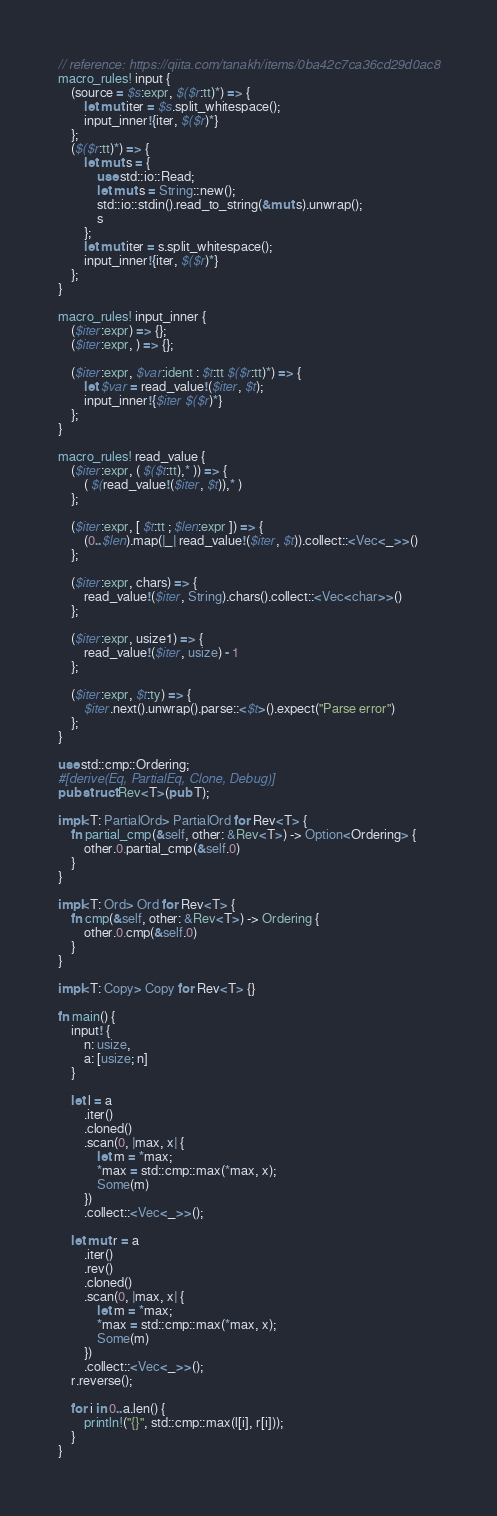<code> <loc_0><loc_0><loc_500><loc_500><_Rust_>// reference: https://qiita.com/tanakh/items/0ba42c7ca36cd29d0ac8
macro_rules! input {
    (source = $s:expr, $($r:tt)*) => {
        let mut iter = $s.split_whitespace();
        input_inner!{iter, $($r)*}
    };
    ($($r:tt)*) => {
        let mut s = {
            use std::io::Read;
            let mut s = String::new();
            std::io::stdin().read_to_string(&mut s).unwrap();
            s
        };
        let mut iter = s.split_whitespace();
        input_inner!{iter, $($r)*}
    };
}

macro_rules! input_inner {
    ($iter:expr) => {};
    ($iter:expr, ) => {};

    ($iter:expr, $var:ident : $t:tt $($r:tt)*) => {
        let $var = read_value!($iter, $t);
        input_inner!{$iter $($r)*}
    };
}

macro_rules! read_value {
    ($iter:expr, ( $($t:tt),* )) => {
        ( $(read_value!($iter, $t)),* )
    };

    ($iter:expr, [ $t:tt ; $len:expr ]) => {
        (0..$len).map(|_| read_value!($iter, $t)).collect::<Vec<_>>()
    };

    ($iter:expr, chars) => {
        read_value!($iter, String).chars().collect::<Vec<char>>()
    };

    ($iter:expr, usize1) => {
        read_value!($iter, usize) - 1
    };

    ($iter:expr, $t:ty) => {
        $iter.next().unwrap().parse::<$t>().expect("Parse error")
    };
}

use std::cmp::Ordering;
#[derive(Eq, PartialEq, Clone, Debug)]
pub struct Rev<T>(pub T);

impl<T: PartialOrd> PartialOrd for Rev<T> {
    fn partial_cmp(&self, other: &Rev<T>) -> Option<Ordering> {
        other.0.partial_cmp(&self.0)
    }
}

impl<T: Ord> Ord for Rev<T> {
    fn cmp(&self, other: &Rev<T>) -> Ordering {
        other.0.cmp(&self.0)
    }
}

impl<T: Copy> Copy for Rev<T> {}

fn main() {
    input! {
        n: usize,
        a: [usize; n]
    }

    let l = a
        .iter()
        .cloned()
        .scan(0, |max, x| {
            let m = *max;
            *max = std::cmp::max(*max, x);
            Some(m)
        })
        .collect::<Vec<_>>();

    let mut r = a
        .iter()
        .rev()
        .cloned()
        .scan(0, |max, x| {
            let m = *max;
            *max = std::cmp::max(*max, x);
            Some(m)
        })
        .collect::<Vec<_>>();
    r.reverse();

    for i in 0..a.len() {
        println!("{}", std::cmp::max(l[i], r[i]));
    }
}
</code> 